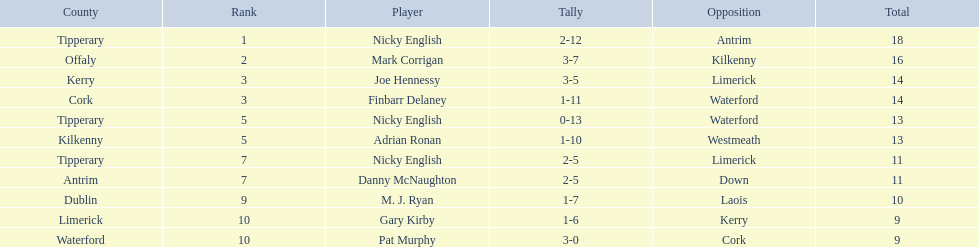What numbers are in the total column? 18, 16, 14, 14, 13, 13, 11, 11, 10, 9, 9. What row has the number 10 in the total column? 9, M. J. Ryan, Dublin, 1-7, 10, Laois. What name is in the player column for this row? M. J. Ryan. 